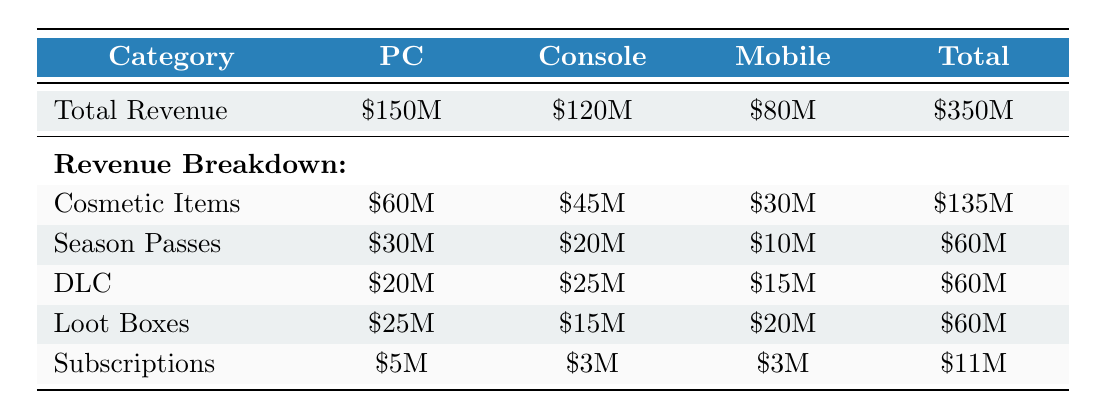What is the total revenue generated from in-game purchases on PC? From the table, the total revenue for in-game purchases on PC is listed directly under the PC column, which states it is 150 million dollars.
Answer: 150 million dollars Which platform generated the least revenue from in-game purchases? By comparing the total revenue values under each platform, PC has 150 million, Console has 120 million, and Mobile has 80 million. Since 80 million is the lowest value, Mobile generated the least revenue.
Answer: Mobile What is the total revenue from cosmetic items across all platforms? The revenue from cosmetic items for each platform is noted as 60 million for PC, 45 million for Console, and 30 million for Mobile. Summing these gives 60 + 45 + 30 = 135 million dollars.
Answer: 135 million dollars Are Season Passes a higher revenue source on Console than on Mobile? The revenue from Season Passes is 20 million on Console and 10 million on Mobile. Since 20 million is greater than 10 million, it confirms that Season Passes generate higher revenue on Console.
Answer: Yes What percentage of the total revenue does PC contribute to all platforms combined? The total revenue for all platforms combined is 350 million (150M + 120M + 80M). PC's contribution is 150 million. The percentage is calculated as (150/350) * 100, which equals approximately 42.86%.
Answer: Approximately 42.86% Which revenue source has the highest value on the Console platform? Looking at the revenue breakdown for Console, Cosmetic Items at 45 million is the highest value compared to the other sources (20 million for Season Passes, 25 million for DLC, 15 million for Loot Boxes, and 3 million for Subscriptions).
Answer: Cosmetic Items How much more revenue does the DLC category contribute on Console compared to Mobile? The revenue from DLC for Console is 25 million and for Mobile is 15 million. The difference is calculated as 25 million - 15 million = 10 million dollars.
Answer: 10 million dollars What revenue source accounts for the majority of total purchases on Mobile? By reviewing the revenue breakdown for Mobile, the highest amount is found in Loot Boxes at 20 million, compared to 30 million for Cosmetic Items, 10 million for Season Passes, and 15 million for DLC. Thus, Cosmetic Items account for the majority on Mobile.
Answer: Cosmetic Items Is the total revenue from subscriptions higher on PC than on Console? The subscription revenue is listed as 5 million on PC and 3 million on Console. Since 5 million is greater than 3 million, it confirms that PC has a higher subscription revenue.
Answer: Yes 